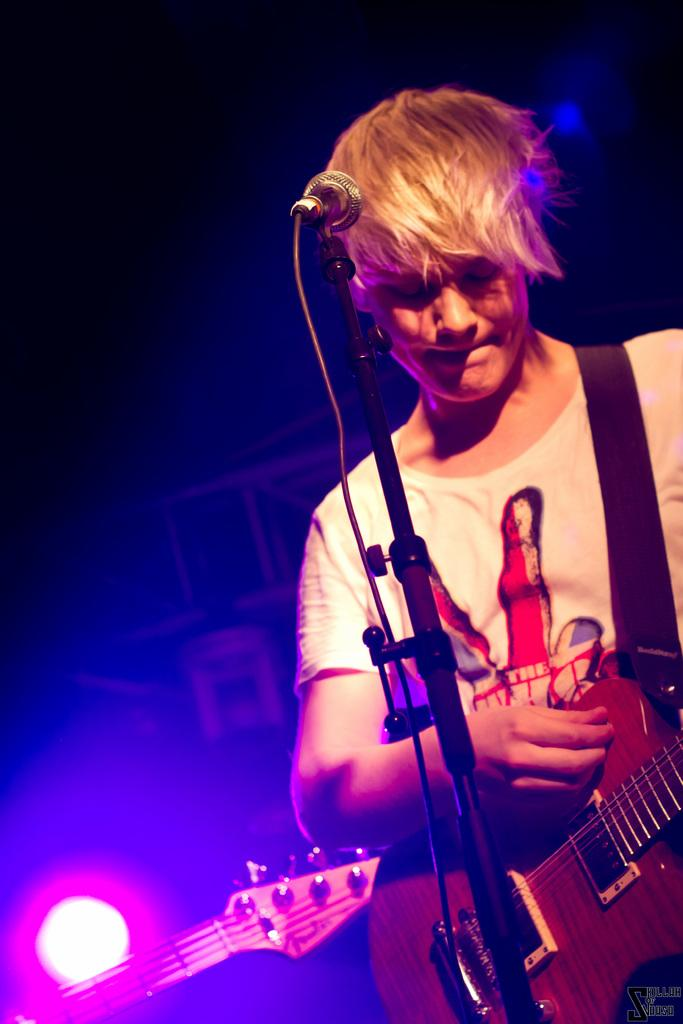Who is the main subject in the image? There is a man in the image. What is the man holding in his hand? The man is holding a guitar in his hand. What object is in front of the man? There is a microphone (mic) in front of the man. What type of wood can be seen in the image? There is no wood visible in the image. What activity is the man engaging in during recess? The image does not depict a recess or any activity related to it. 